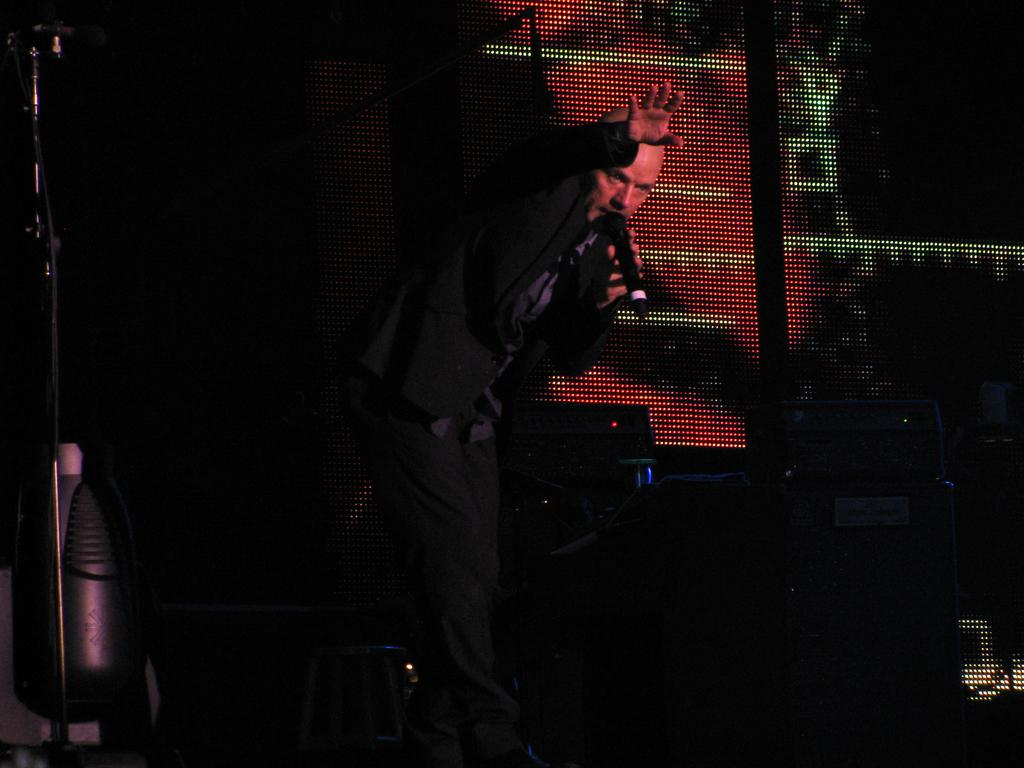What is the main subject of the image? The main subject of the image is a man. What is the man wearing in the image? The man is wearing a black blazer. What is the man holding in the image? The man is holding a microphone. What can be seen behind the man in the image? There are objects visible behind the man. What is the man's opinion on the latest political developments, as expressed in the image? The image does not provide any information about the man's opinion on political developments. 